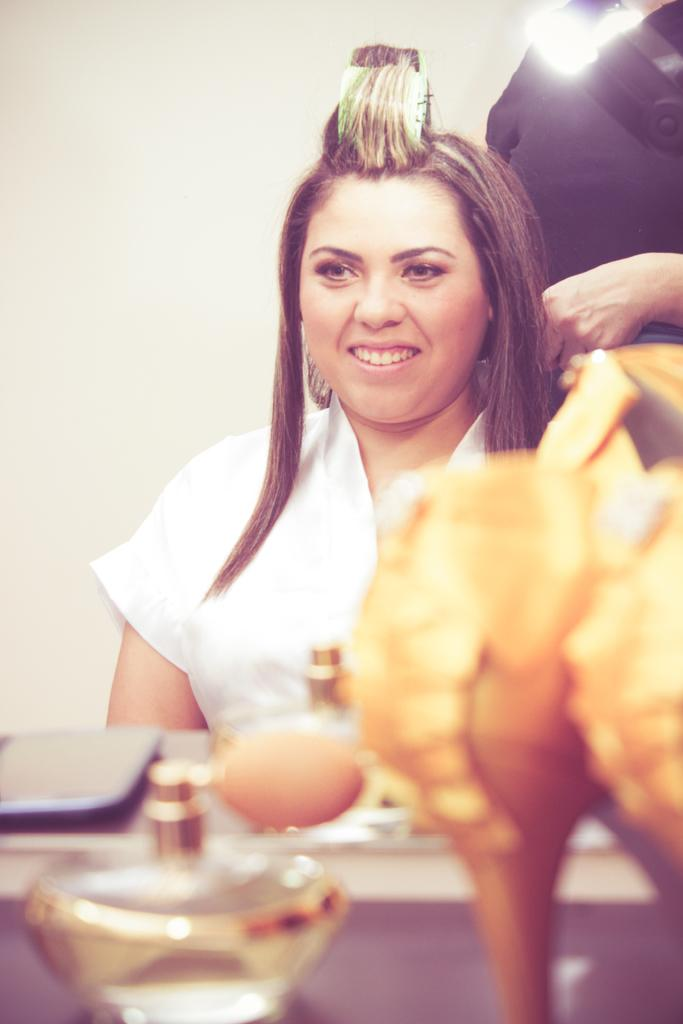Who or what can be seen in the image? There are people in the image. What objects are on a stand in the image? There are objects on a stand, including bottles. What type of light is visible at the top of the image? There is a light at the top of the image. What can be seen in the background of the image? There is a wall in the background of the image. What type of peace symbol can be seen on the door in the image? There is no door present in the image, and therefore no peace symbol can be observed. 